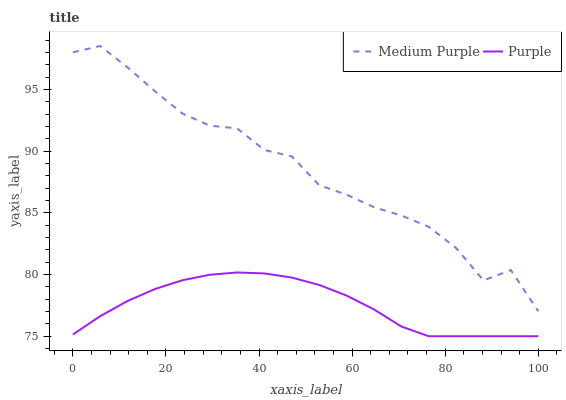Does Purple have the minimum area under the curve?
Answer yes or no. Yes. Does Medium Purple have the maximum area under the curve?
Answer yes or no. Yes. Does Purple have the maximum area under the curve?
Answer yes or no. No. Is Purple the smoothest?
Answer yes or no. Yes. Is Medium Purple the roughest?
Answer yes or no. Yes. Is Purple the roughest?
Answer yes or no. No. Does Purple have the lowest value?
Answer yes or no. Yes. Does Medium Purple have the highest value?
Answer yes or no. Yes. Does Purple have the highest value?
Answer yes or no. No. Is Purple less than Medium Purple?
Answer yes or no. Yes. Is Medium Purple greater than Purple?
Answer yes or no. Yes. Does Purple intersect Medium Purple?
Answer yes or no. No. 